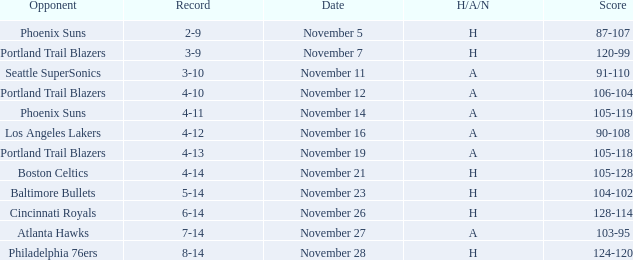What is the Opponent of the game with a H/A/N of H and Score of 120-99? Portland Trail Blazers. 